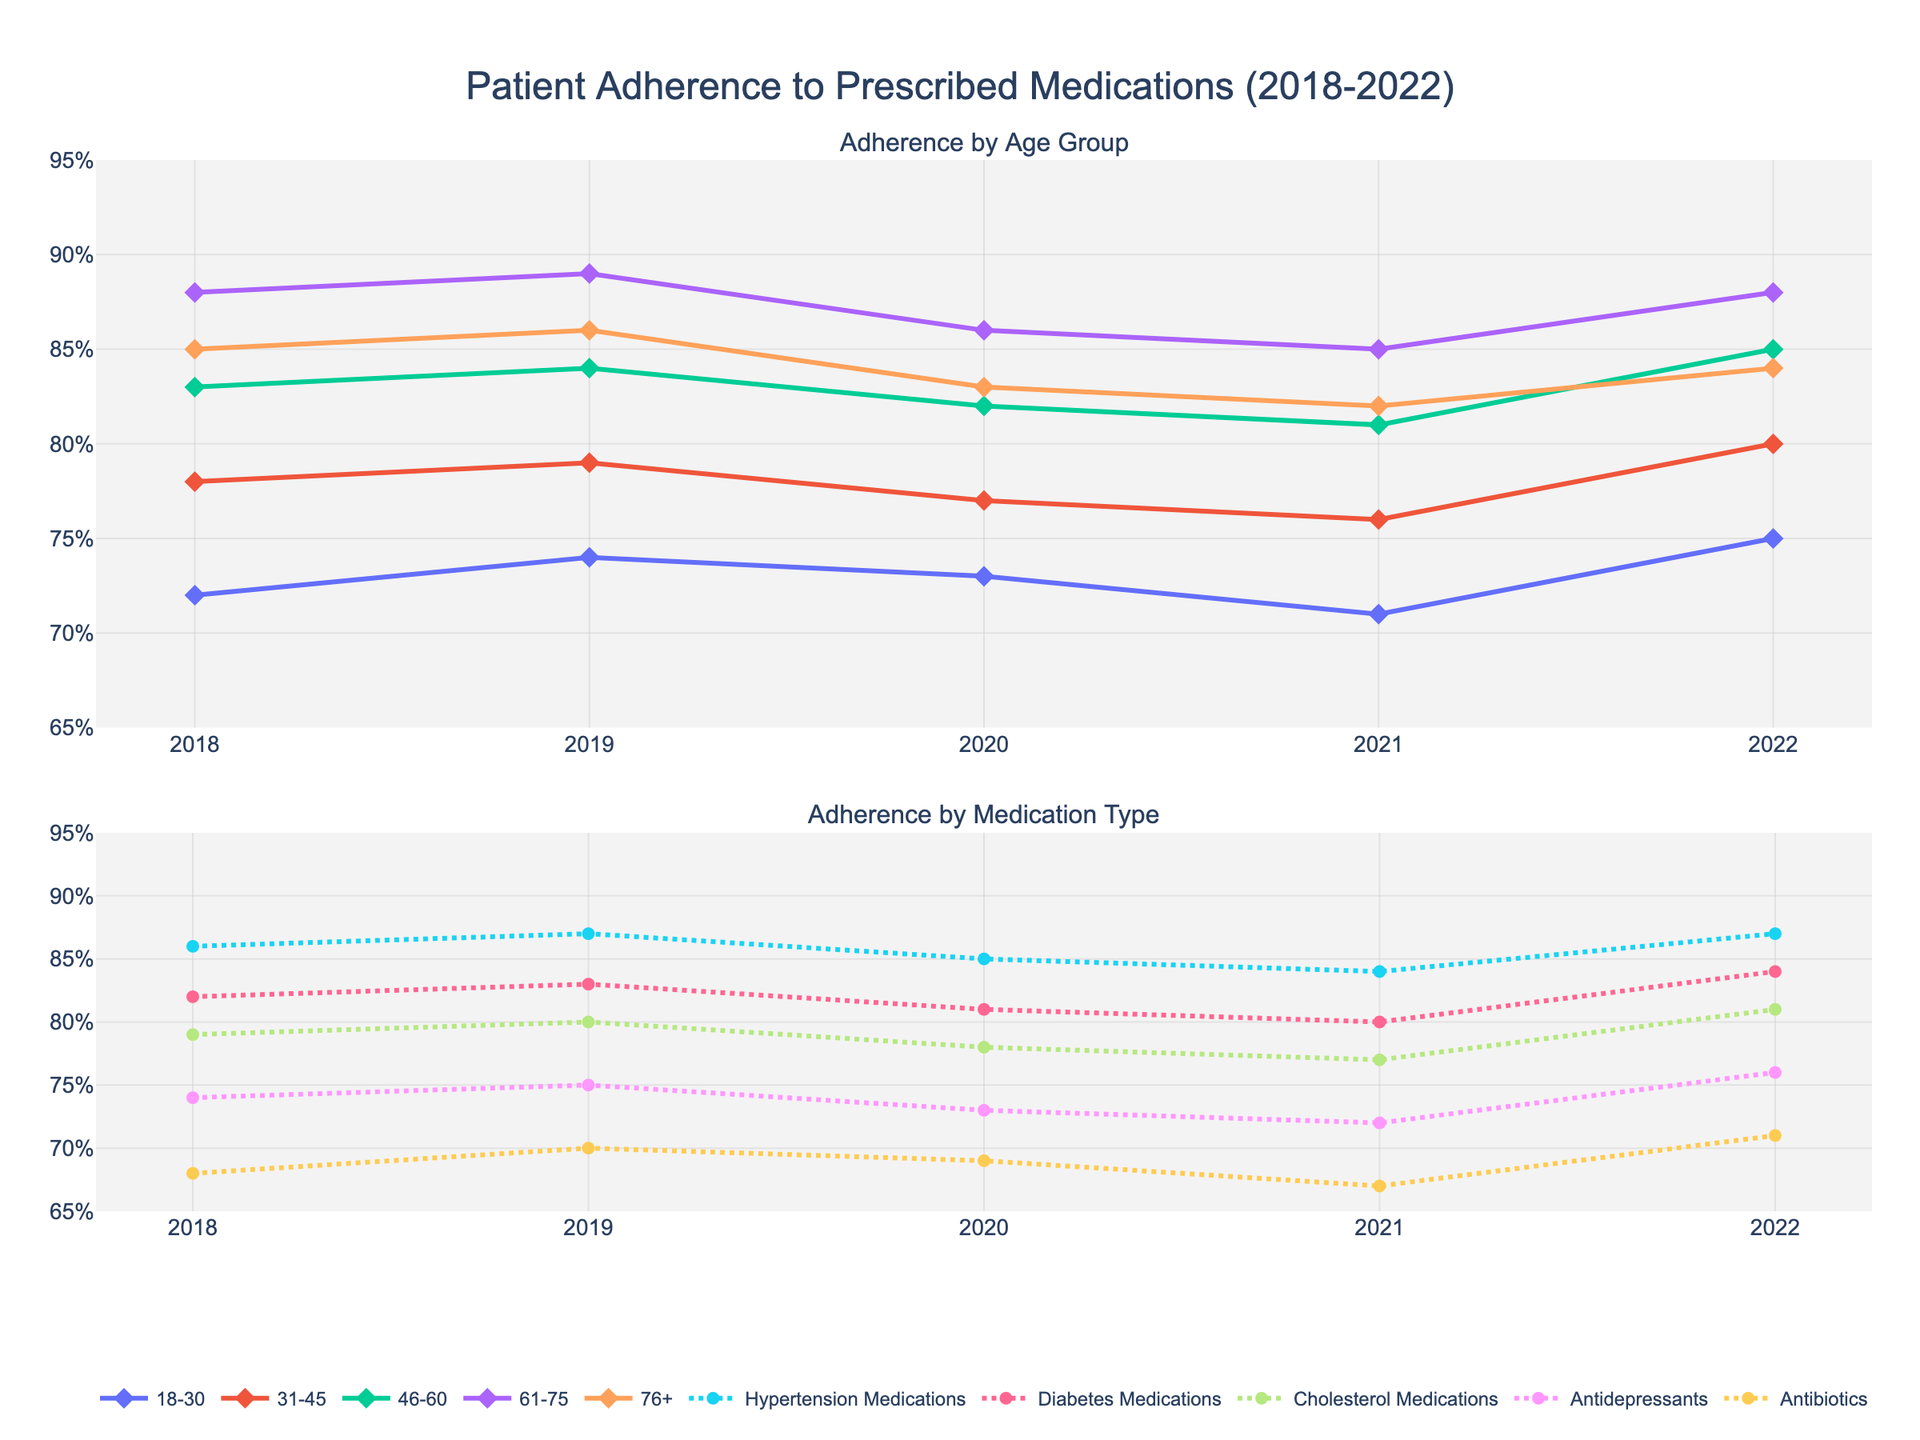Which age group saw the highest adherence rate in 2020? Look at the chart for age groups in the year 2020. The data points show adherence rates for each group in that year. The highest adherence is for the 61-75 age group with 86%.
Answer: 61-75 Which medication type had the most significant increase in adherence rate from 2021 to 2022? Look at the chart for medication types. Calculate the difference in adherence rates from 2021 to 2022 for each medication. Antidepressants increased from 72% to 76%, which is the largest increase of 4%.
Answer: Antidepressants What was the overall trend for adherence in the 46-60 age group between 2018 and 2022? Observe the chart for the 46-60 age group. Note the adherence rates for each year from 2018 to 2022: 83%, 84%, 82%, 81%, and 85%. The general trend is relatively stable with a slight increase towards the end.
Answer: Slight increase Compare the adherence rates of hypertension and diabetes medications in 2019. Which one was higher? Look at the chart for 2019 and find the adherence rates for hypertension and diabetes medications. Hypertension medications had an 87% adherence rate, while diabetes medications had 83%.
Answer: Hypertension medications Calculate the average adherence rate for the 31-45 age group over the 5-year period. Sum the adherence rates for the 31-45 age group across the years: 78% + 79% + 77% + 76% + 80%. The total is 390%. Dividing by 5 years gives an average of 78%.
Answer: 78% Which age group experienced a decrease in adherence rate each consecutive year from 2019 to 2021? Look at the adherence rates for each age group and identify the trends between 2019, 2020, and 2021. The 76+ group shows a decrease from 86% to 83% to 82% across these years.
Answer: 76+ How did adherence to antibiotic medications change from 2018 to 2022? Look at the adherence rates for antibiotic medications for each year: 68%, 70%, 69%, 67%, 71%. There is a slight fluctuation with a notable increase from 67% to 71% in 2022.
Answer: Slight increase Which age group had the smallest variation in adherence rates from 2018 to 2022? Find the range of adherence rates for each age group between 2018 and 2022. The 61-75 age group varied between 85% and 89%, showing the smallest variation of 4%.
Answer: 61-75 What was the trend in adherence rates for cholesterol medications from 2018 to 2022? Observe the chart for cholesterol medications. Note the adherence rates: 79%, 80%, 78%, 77%, 81%. The trend shows a slight decrease with a small increase in 2022.
Answer: Slight decrease 